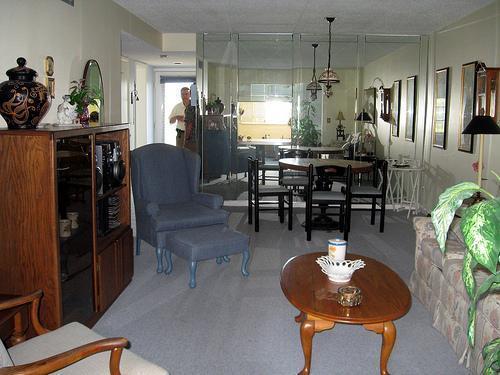How many couches are shown?
Give a very brief answer. 1. How many people are shown?
Give a very brief answer. 2. 